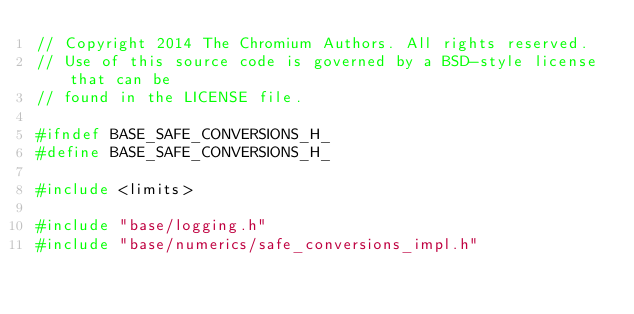Convert code to text. <code><loc_0><loc_0><loc_500><loc_500><_C_>// Copyright 2014 The Chromium Authors. All rights reserved.
// Use of this source code is governed by a BSD-style license that can be
// found in the LICENSE file.

#ifndef BASE_SAFE_CONVERSIONS_H_
#define BASE_SAFE_CONVERSIONS_H_

#include <limits>

#include "base/logging.h"
#include "base/numerics/safe_conversions_impl.h"
</code> 